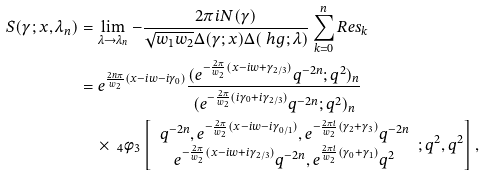<formula> <loc_0><loc_0><loc_500><loc_500>S ( \gamma ; x , \lambda _ { n } ) & = \lim _ { \lambda \to \lambda _ { n } } - \frac { 2 \pi i N ( \gamma ) } { \sqrt { w _ { 1 } w _ { 2 } } \Delta ( \gamma ; x ) \Delta ( \ h g ; \lambda ) } \sum _ { k = 0 } ^ { n } R e s _ { k } \\ & = e ^ { \frac { 2 n \pi } { w _ { 2 } } ( x - i w - i \gamma _ { 0 } ) } \frac { ( e ^ { - \frac { 2 \pi } { w _ { 2 } } ( x - i w + \gamma _ { 2 / 3 } ) } q ^ { - 2 n } ; q ^ { 2 } ) _ { n } } { ( e ^ { - \frac { 2 \pi } { w _ { 2 } } ( i \gamma _ { 0 } + i \gamma _ { 2 / 3 } ) } q ^ { - 2 n } ; q ^ { 2 } ) _ { n } } \\ & \quad \times \ _ { 4 } \phi _ { 3 } \left [ \begin{array} { c } q ^ { - 2 n } , e ^ { - \frac { 2 \pi } { w _ { 2 } } ( x - i w - i \gamma _ { 0 / 1 } ) } , e ^ { - \frac { 2 \pi i } { w _ { 2 } } ( \gamma _ { 2 } + \gamma _ { 3 } ) } q ^ { - 2 n } \\ e ^ { - \frac { 2 \pi } { w _ { 2 } } ( x - i w + i \gamma _ { 2 / 3 } ) } q ^ { - 2 n } , e ^ { \frac { 2 \pi i } { w _ { 2 } } ( \gamma _ { 0 } + \gamma _ { 1 } ) } q ^ { 2 } \end{array} ; q ^ { 2 } , q ^ { 2 } \right ] ,</formula> 